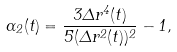<formula> <loc_0><loc_0><loc_500><loc_500>\alpha _ { 2 } ( t ) = \frac { 3 \Delta r ^ { 4 } ( t ) } { 5 ( \Delta r ^ { 2 } ( t ) ) ^ { 2 } } - 1 ,</formula> 